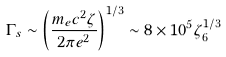<formula> <loc_0><loc_0><loc_500><loc_500>\Gamma _ { s } \sim \left ( \frac { m _ { e } c ^ { 2 } \zeta } { 2 \pi e ^ { 2 } } \right ) ^ { 1 / 3 } \sim 8 \times 1 0 ^ { 5 } \zeta _ { 6 } ^ { 1 / 3 }</formula> 